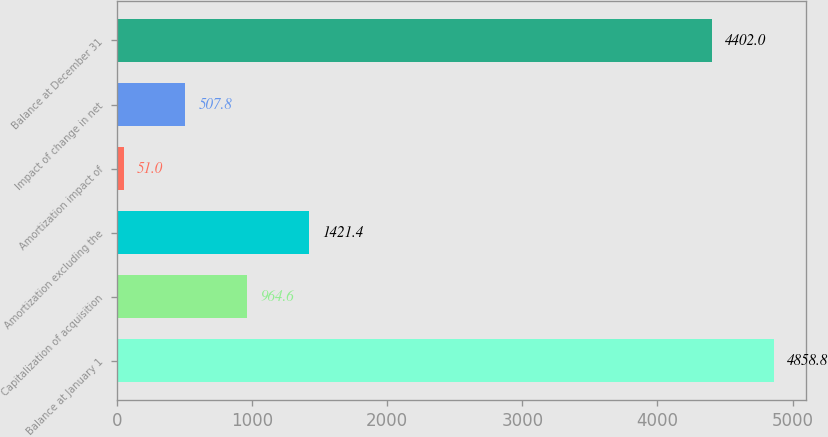Convert chart to OTSL. <chart><loc_0><loc_0><loc_500><loc_500><bar_chart><fcel>Balance at January 1<fcel>Capitalization of acquisition<fcel>Amortization excluding the<fcel>Amortization impact of<fcel>Impact of change in net<fcel>Balance at December 31<nl><fcel>4858.8<fcel>964.6<fcel>1421.4<fcel>51<fcel>507.8<fcel>4402<nl></chart> 